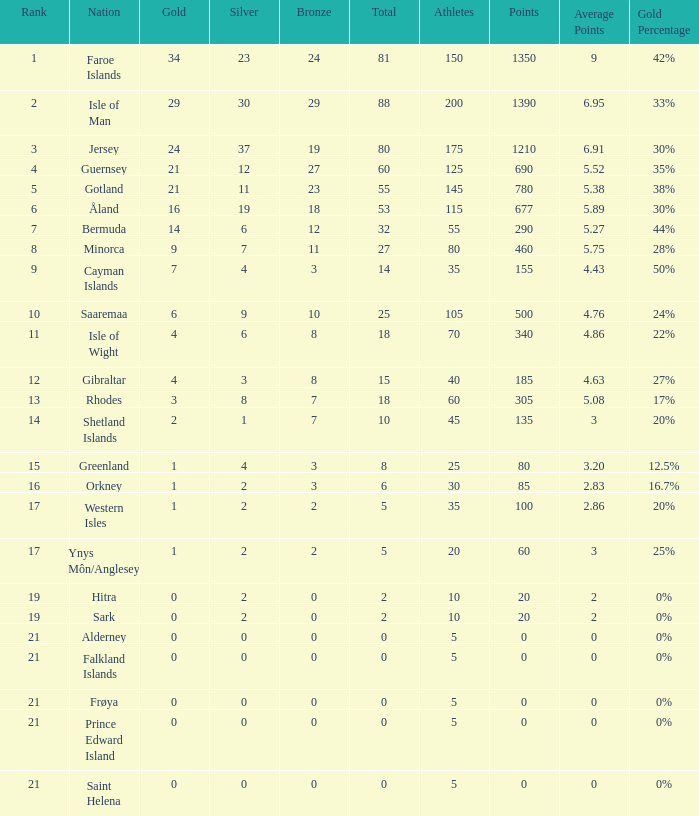How many Silver medals were won in total by all those with more than 3 bronze and exactly 16 gold? 19.0. 